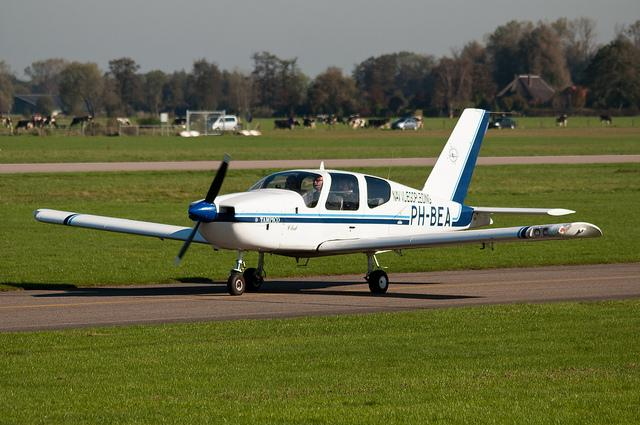What type of settlements are near the airport?

Choices:
A) sky scrapers
B) tennis clubs
C) farm
D) power plant farm 